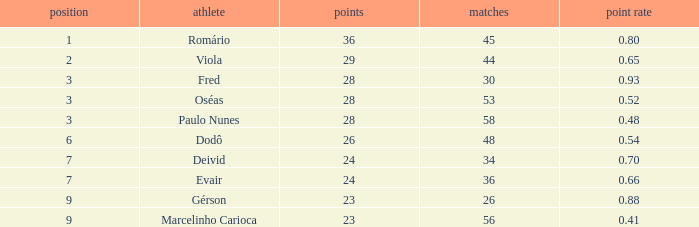8 during 56 competitions? 1.0. 